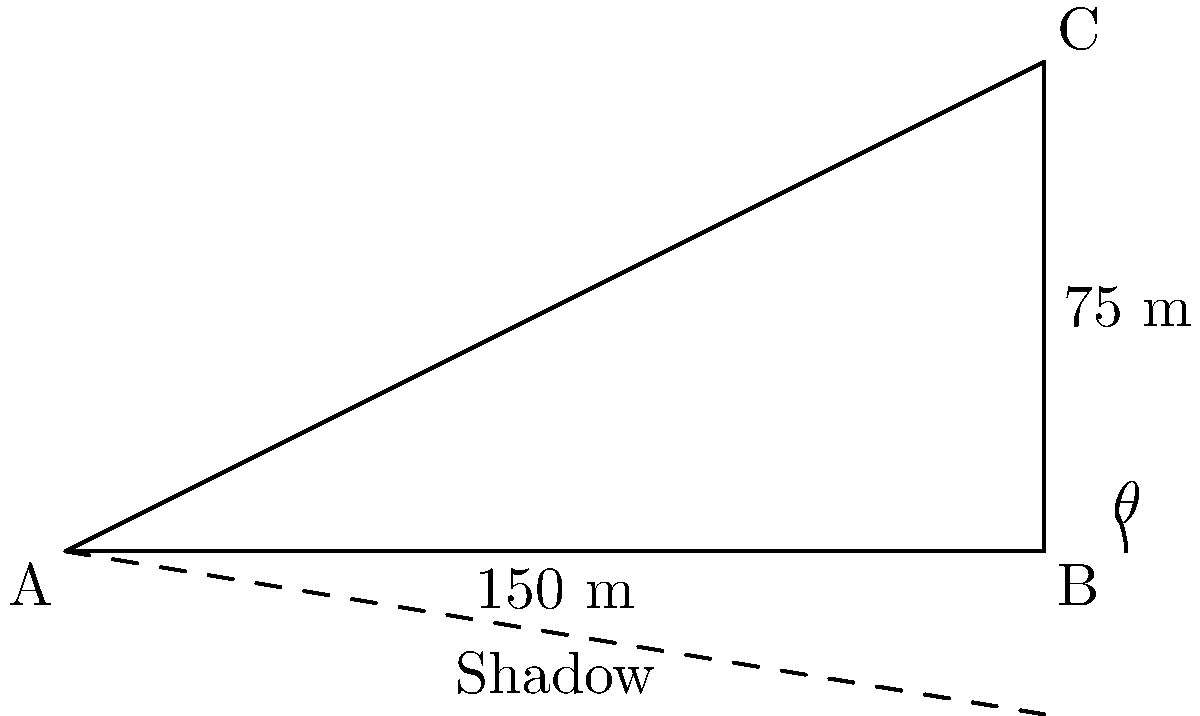As a successful tech entrepreneur, you're considering investing in a new skyscraper project. To evaluate the project's feasibility, you need to calculate the height of the proposed building. On a sunny day, you observe that the skyscraper casts a shadow 150 meters long. Using your smartphone's inclinometer app, you measure the angle of elevation from the tip of the shadow to the top of the building to be $\theta = 26.57°$. What is the height of the skyscraper to the nearest meter? Let's approach this step-by-step:

1) We can model this situation as a right-angled triangle, where:
   - The shadow length is the base of the triangle (adjacent to angle $\theta$)
   - The height of the skyscraper is the opposite side to angle $\theta$
   - The line from the top of the skyscraper to the end of the shadow is the hypotenuse

2) We know the adjacent side (shadow length) and the angle $\theta$. We need to find the opposite side (skyscraper height).

3) The trigonometric ratio that relates the opposite side to the adjacent side is the tangent:

   $\tan \theta = \frac{\text{opposite}}{\text{adjacent}} = \frac{\text{height}}{\text{shadow length}}$

4) Let's call the height $h$. We can write the equation:

   $\tan 26.57° = \frac{h}{150}$

5) To solve for $h$, multiply both sides by 150:

   $h = 150 \times \tan 26.57°$

6) Using a calculator or computer:

   $h = 150 \times 0.4999 = 74.985$ meters

7) Rounding to the nearest meter:

   $h \approx 75$ meters
Answer: 75 meters 